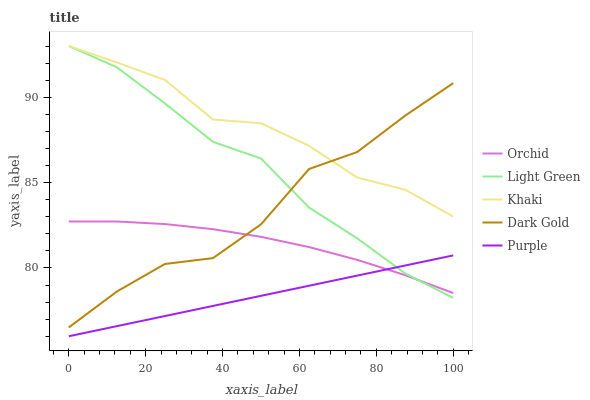Does Purple have the minimum area under the curve?
Answer yes or no. Yes. Does Khaki have the maximum area under the curve?
Answer yes or no. Yes. Does Khaki have the minimum area under the curve?
Answer yes or no. No. Does Purple have the maximum area under the curve?
Answer yes or no. No. Is Purple the smoothest?
Answer yes or no. Yes. Is Dark Gold the roughest?
Answer yes or no. Yes. Is Khaki the smoothest?
Answer yes or no. No. Is Khaki the roughest?
Answer yes or no. No. Does Purple have the lowest value?
Answer yes or no. Yes. Does Khaki have the lowest value?
Answer yes or no. No. Does Light Green have the highest value?
Answer yes or no. Yes. Does Purple have the highest value?
Answer yes or no. No. Is Purple less than Dark Gold?
Answer yes or no. Yes. Is Khaki greater than Purple?
Answer yes or no. Yes. Does Light Green intersect Orchid?
Answer yes or no. Yes. Is Light Green less than Orchid?
Answer yes or no. No. Is Light Green greater than Orchid?
Answer yes or no. No. Does Purple intersect Dark Gold?
Answer yes or no. No. 